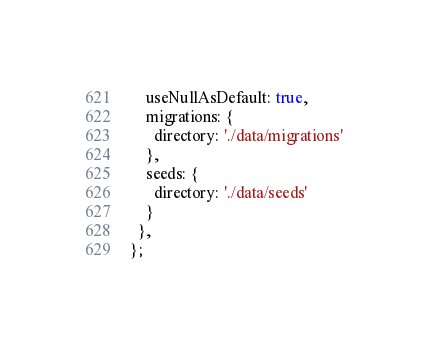Convert code to text. <code><loc_0><loc_0><loc_500><loc_500><_JavaScript_>    useNullAsDefault: true,
    migrations: {
      directory: './data/migrations'
    },
    seeds: {
      directory: './data/seeds'
    }
  },
};
</code> 